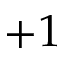Convert formula to latex. <formula><loc_0><loc_0><loc_500><loc_500>+ 1</formula> 